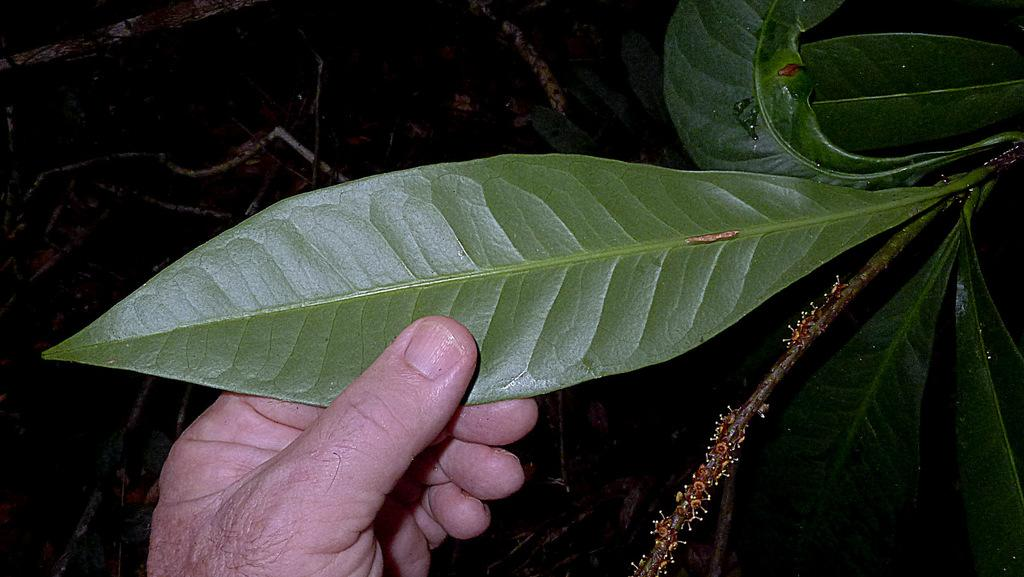What is the main subject of the image? The main subject of the image is a person's hand. What is the hand holding in the image? The hand is holding a leaf. What type of advice is the hand giving in the image? The hand is not giving any advice in the image; it is simply holding a leaf. 